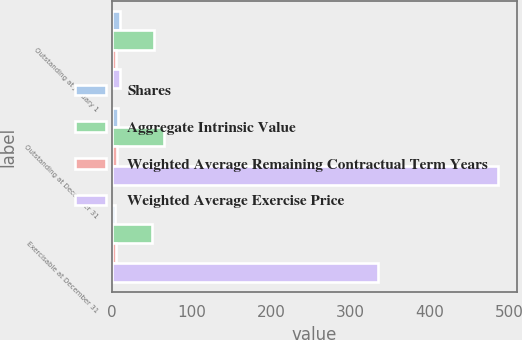<chart> <loc_0><loc_0><loc_500><loc_500><stacked_bar_chart><ecel><fcel>Outstanding at January 1<fcel>Outstanding at December 31<fcel>Exercisable at December 31<nl><fcel>Shares<fcel>9.4<fcel>7.2<fcel>4.1<nl><fcel>Aggregate Intrinsic Value<fcel>53.03<fcel>65.07<fcel>49.92<nl><fcel>Weighted Average Remaining Contractual Term Years<fcel>5.2<fcel>6.7<fcel>5.4<nl><fcel>Weighted Average Exercise Price<fcel>9.4<fcel>485<fcel>334<nl></chart> 